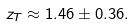<formula> <loc_0><loc_0><loc_500><loc_500>z _ { T } \approx 1 . 4 6 \pm 0 . 3 6 .</formula> 